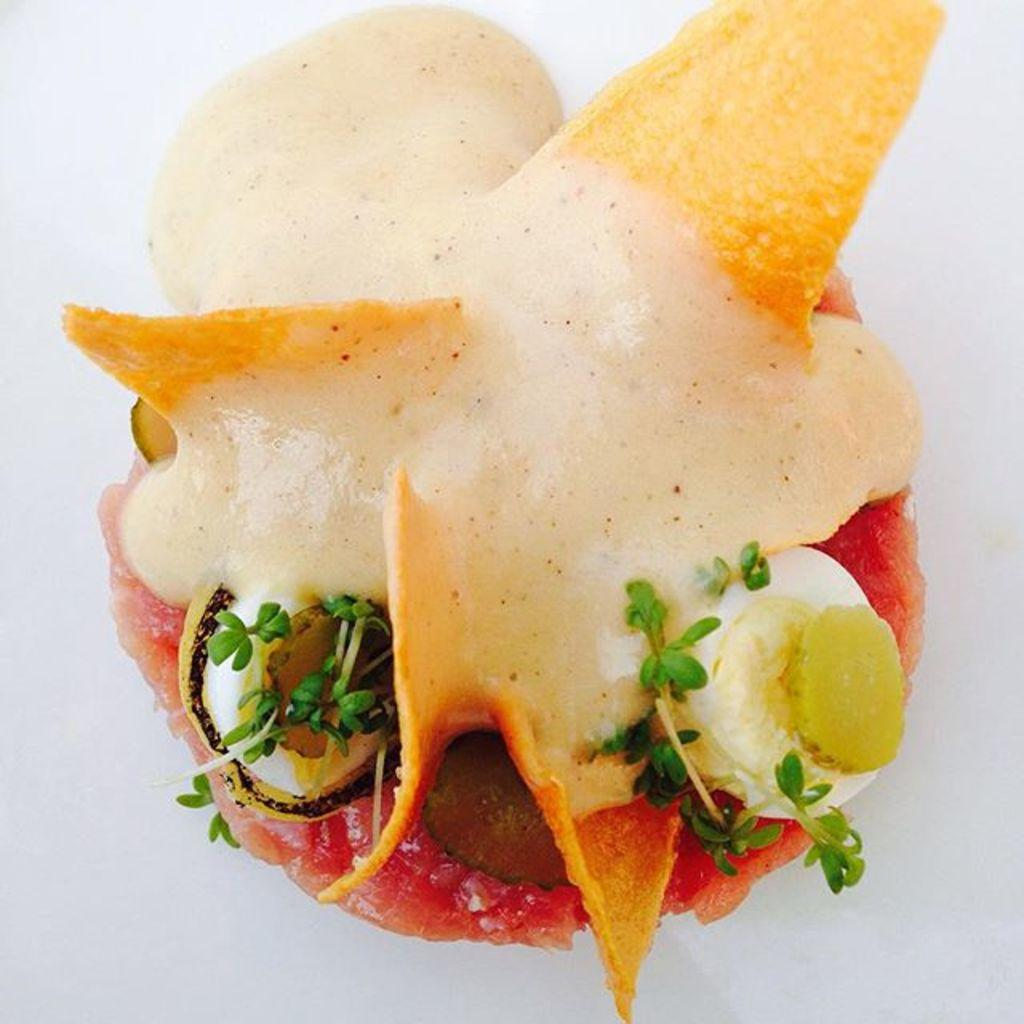What is the main subject of the image? There is a food item in the image. What is the color of the surface on which the food item is placed? The food item is on a white surface. What additional elements can be seen on the food item? There are leaves on the food item. What is the tendency of the tin to swing in the image? There is no tin present in the image, so it cannot be determined if it has a tendency to swing. 